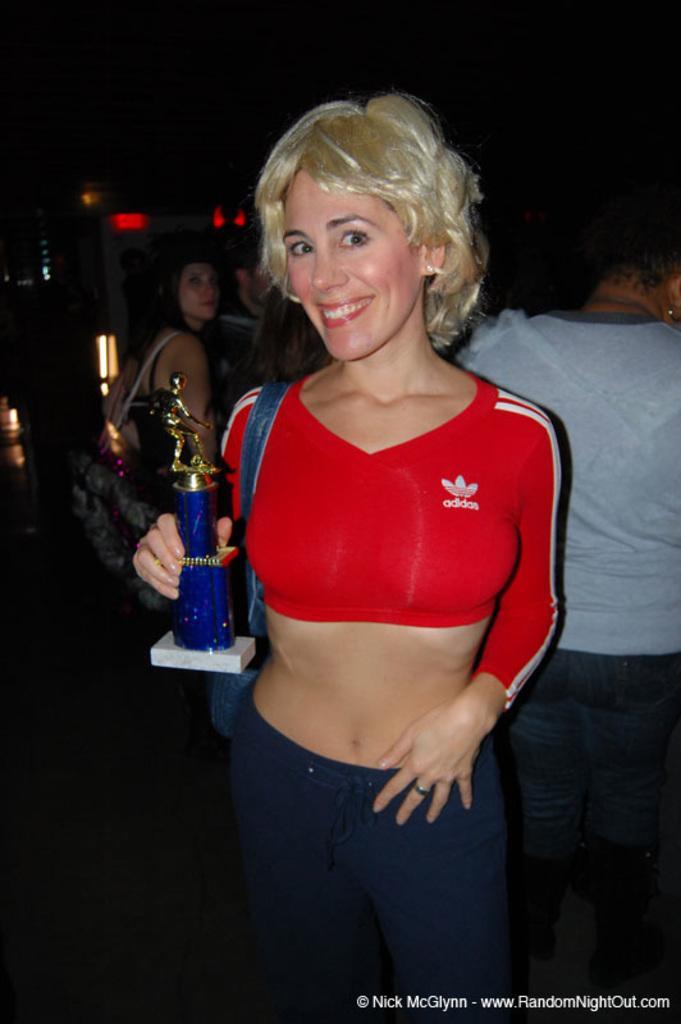Please provide a concise description of this image. Background portion of the picture is dark. In this picture we can see the people. This picture is mainly highlighted with a woman holding an award and she is smiling. At the bottom portion of the picture we can see watermark. 